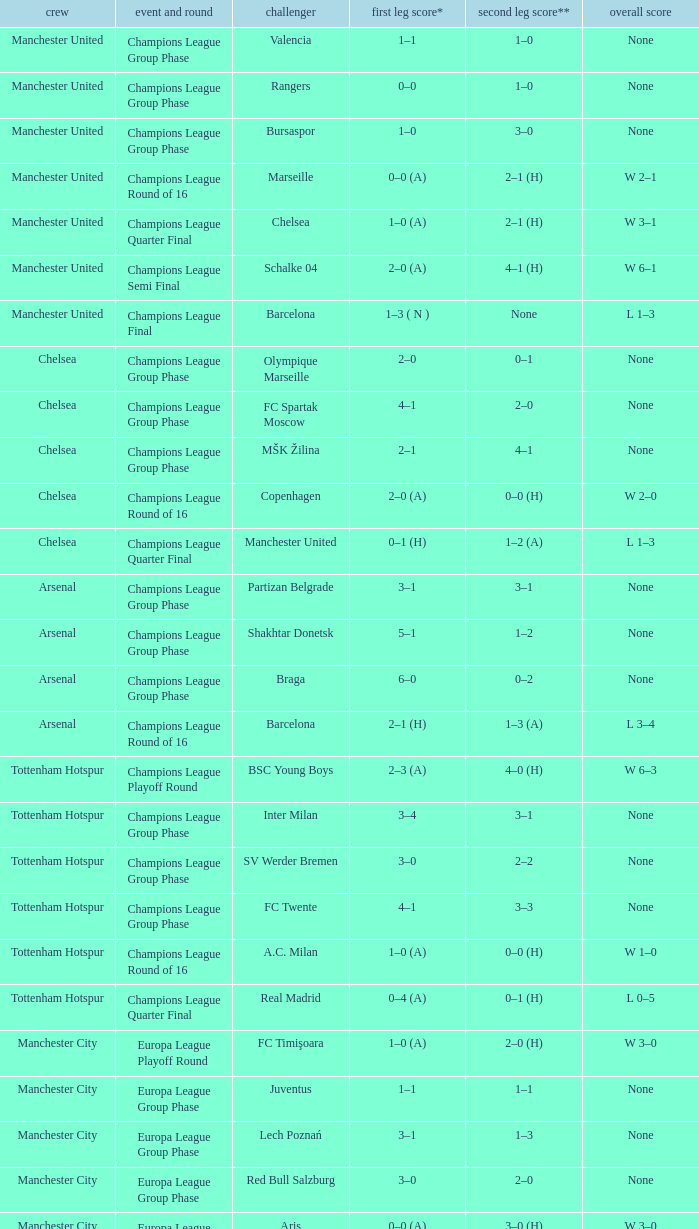What was the score between Marseille and Manchester United on the second leg of the Champions League Round of 16? 2–1 (H). 